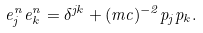Convert formula to latex. <formula><loc_0><loc_0><loc_500><loc_500>e ^ { n } _ { j } e ^ { n } _ { k } = \delta ^ { j k } + ( m c ) ^ { - 2 } p _ { j } p _ { k } .</formula> 